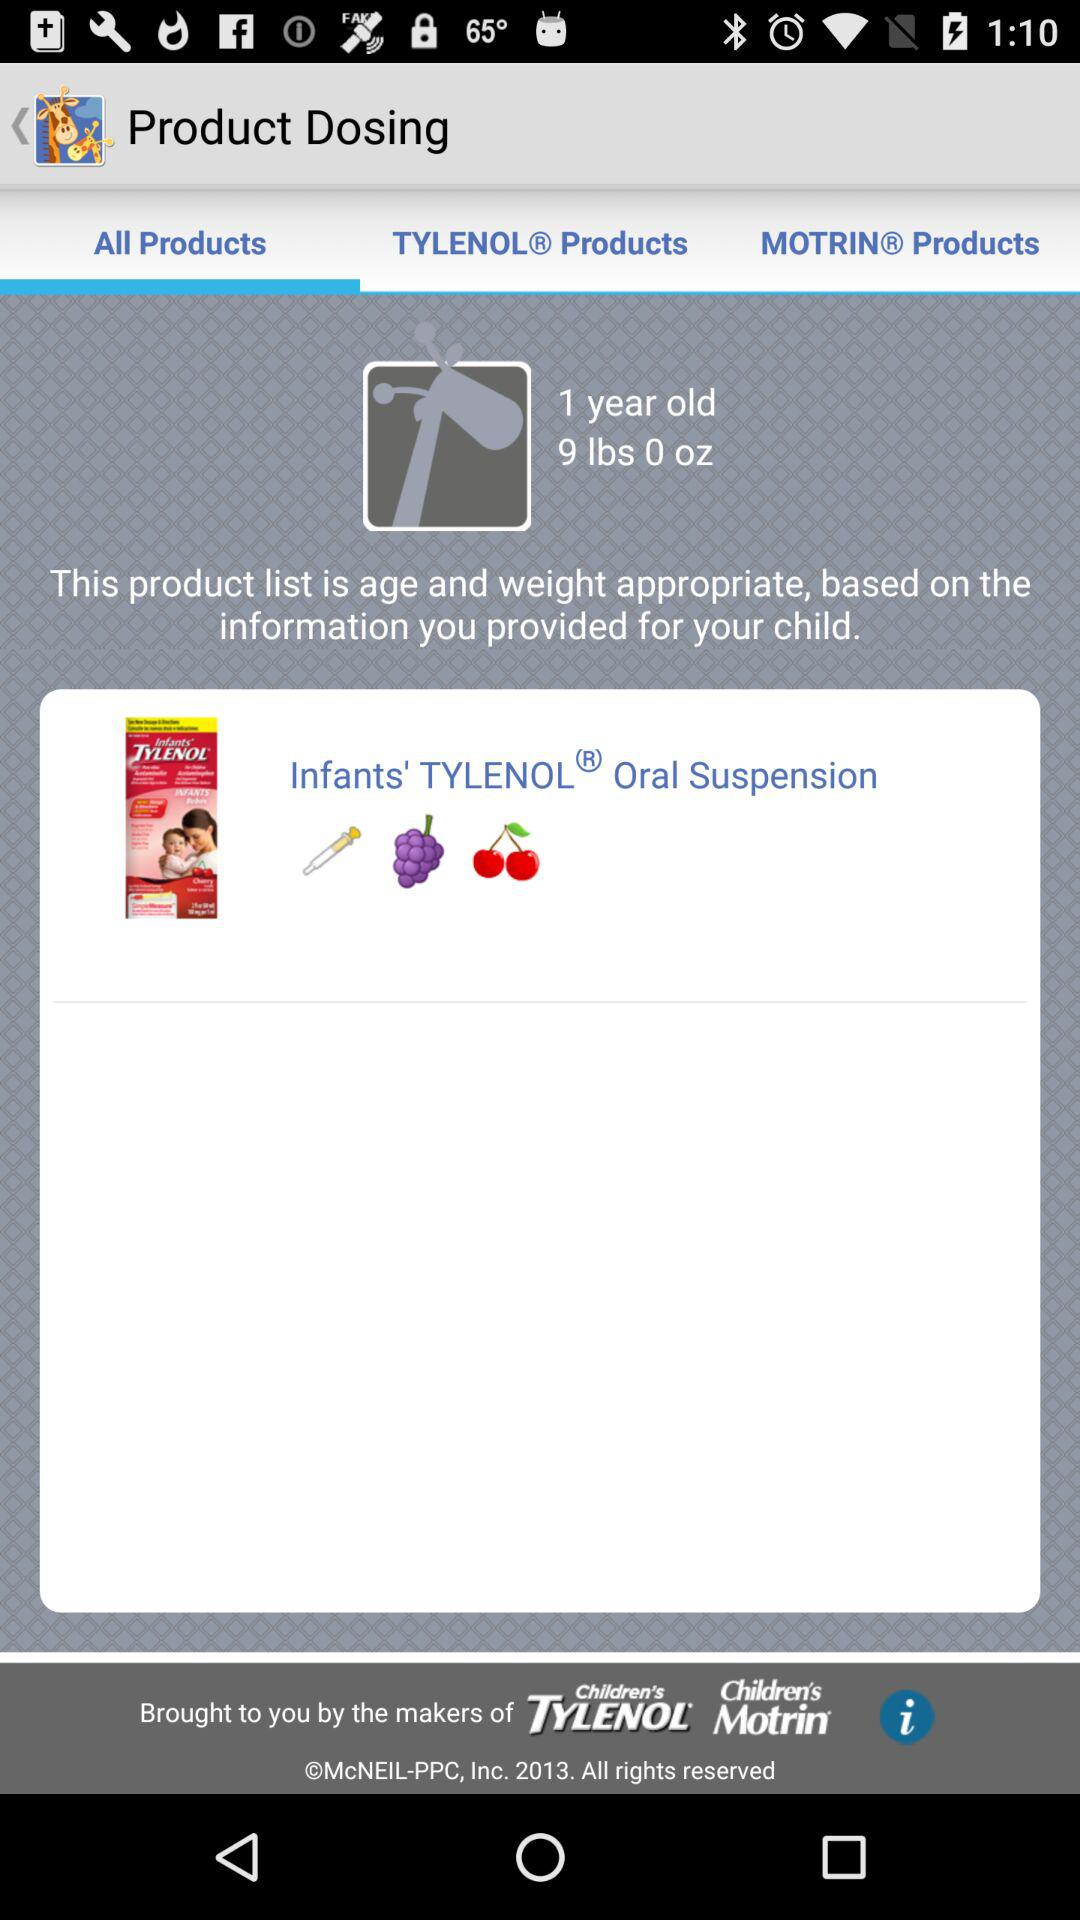Which tab is selected? The selected tab is "All Products". 